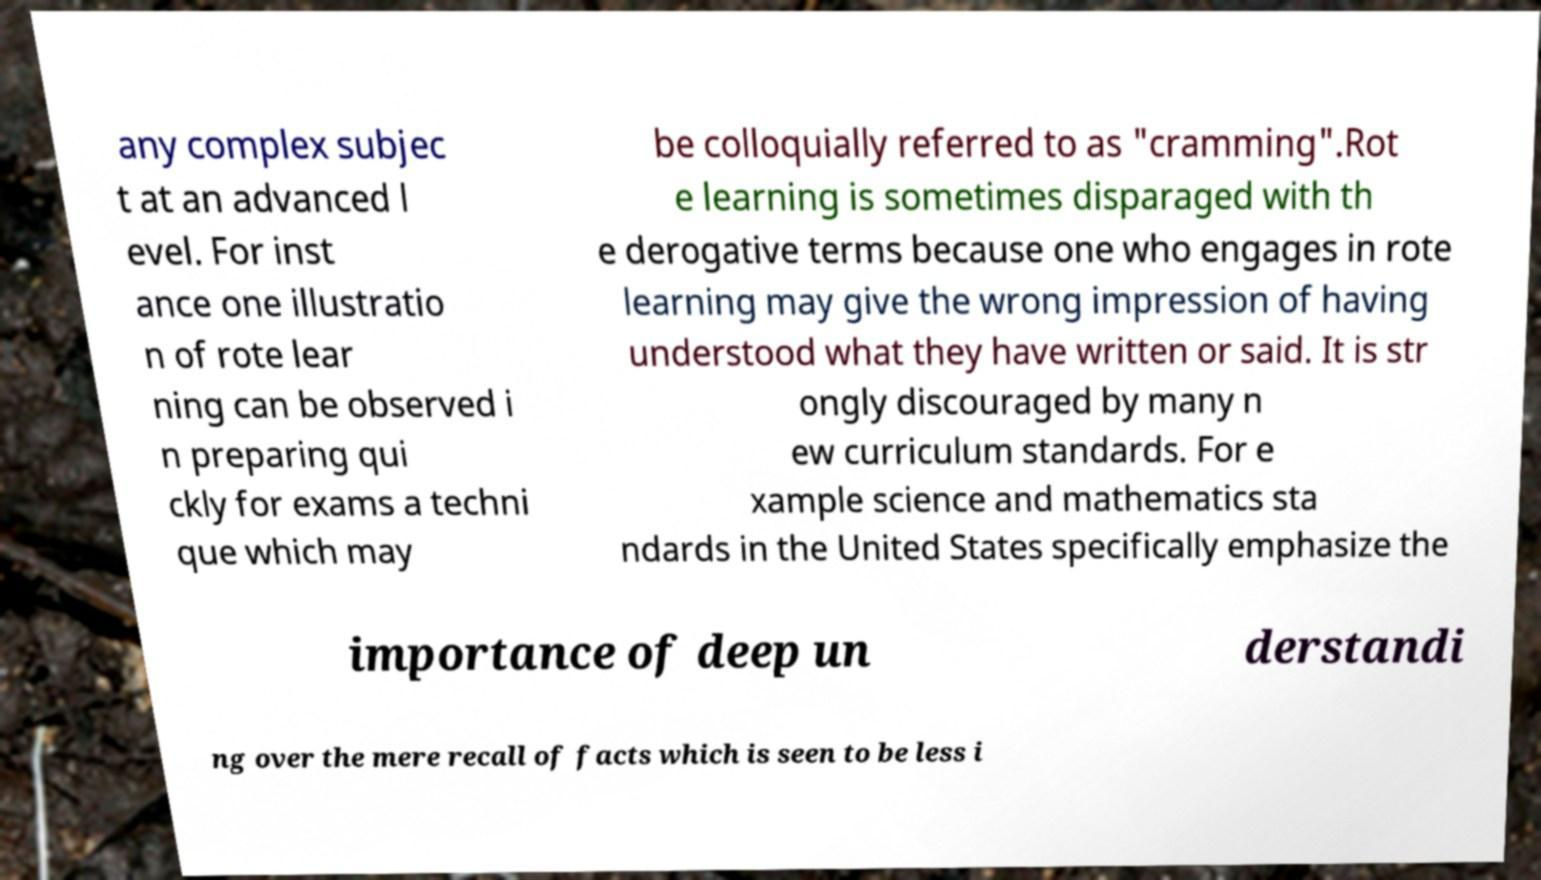Could you extract and type out the text from this image? any complex subjec t at an advanced l evel. For inst ance one illustratio n of rote lear ning can be observed i n preparing qui ckly for exams a techni que which may be colloquially referred to as "cramming".Rot e learning is sometimes disparaged with th e derogative terms because one who engages in rote learning may give the wrong impression of having understood what they have written or said. It is str ongly discouraged by many n ew curriculum standards. For e xample science and mathematics sta ndards in the United States specifically emphasize the importance of deep un derstandi ng over the mere recall of facts which is seen to be less i 